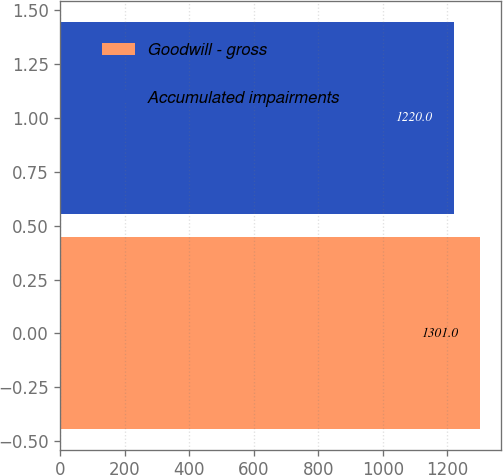<chart> <loc_0><loc_0><loc_500><loc_500><bar_chart><fcel>Goodwill - gross<fcel>Accumulated impairments<nl><fcel>1301<fcel>1220<nl></chart> 